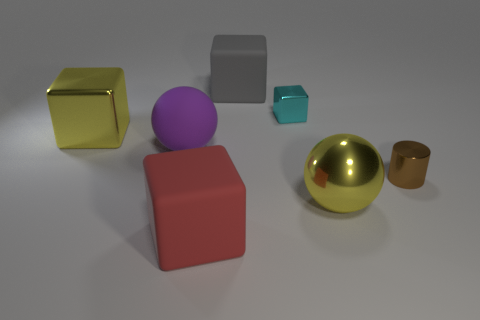Can you describe the lighting in the scene? The scene is illuminated by a soft, diffuse light source that creates gentle shadows on the ground. The shadows are not particularly sharp, suggesting the light source is not very close to the objects. There is a slight bright spot on the surface beneath the objects, which indicates there might be a primary light source positioned above them.  What can you infer about the environment outside of the frame? Given the controlled lighting and the shadows, it's likely that the objects are placed within an indoor environment, possibly a studio setup designed to minimize external lighting influences. The plain, unobtrusive background suggests the focus is on the objects, without any specific context or additional details provided about the surrounding space. 